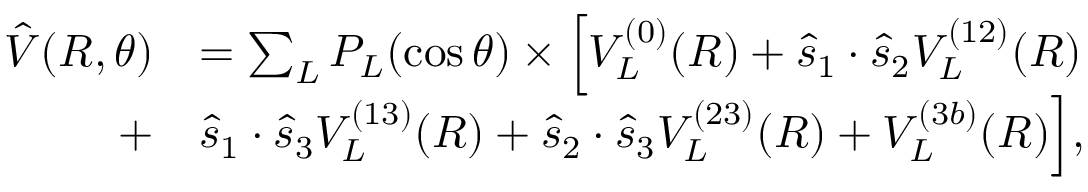Convert formula to latex. <formula><loc_0><loc_0><loc_500><loc_500>\begin{array} { r l } { \hat { V } ( R , \theta ) } & { = \sum _ { L } P _ { L } ( \cos \theta ) \times \left [ V _ { L } ^ { ( 0 ) } ( R ) + \hat { s } _ { 1 } \cdot \hat { s } _ { 2 } V _ { L } ^ { ( 1 2 ) } ( R ) } \\ { + } & { \hat { s } _ { 1 } \cdot \hat { s } _ { 3 } V _ { L } ^ { ( 1 3 ) } ( R ) + \hat { s } _ { 2 } \cdot \hat { s } _ { 3 } V _ { L } ^ { ( 2 3 ) } ( R ) + V _ { L } ^ { ( 3 b ) } ( R ) \right ] , } \end{array}</formula> 